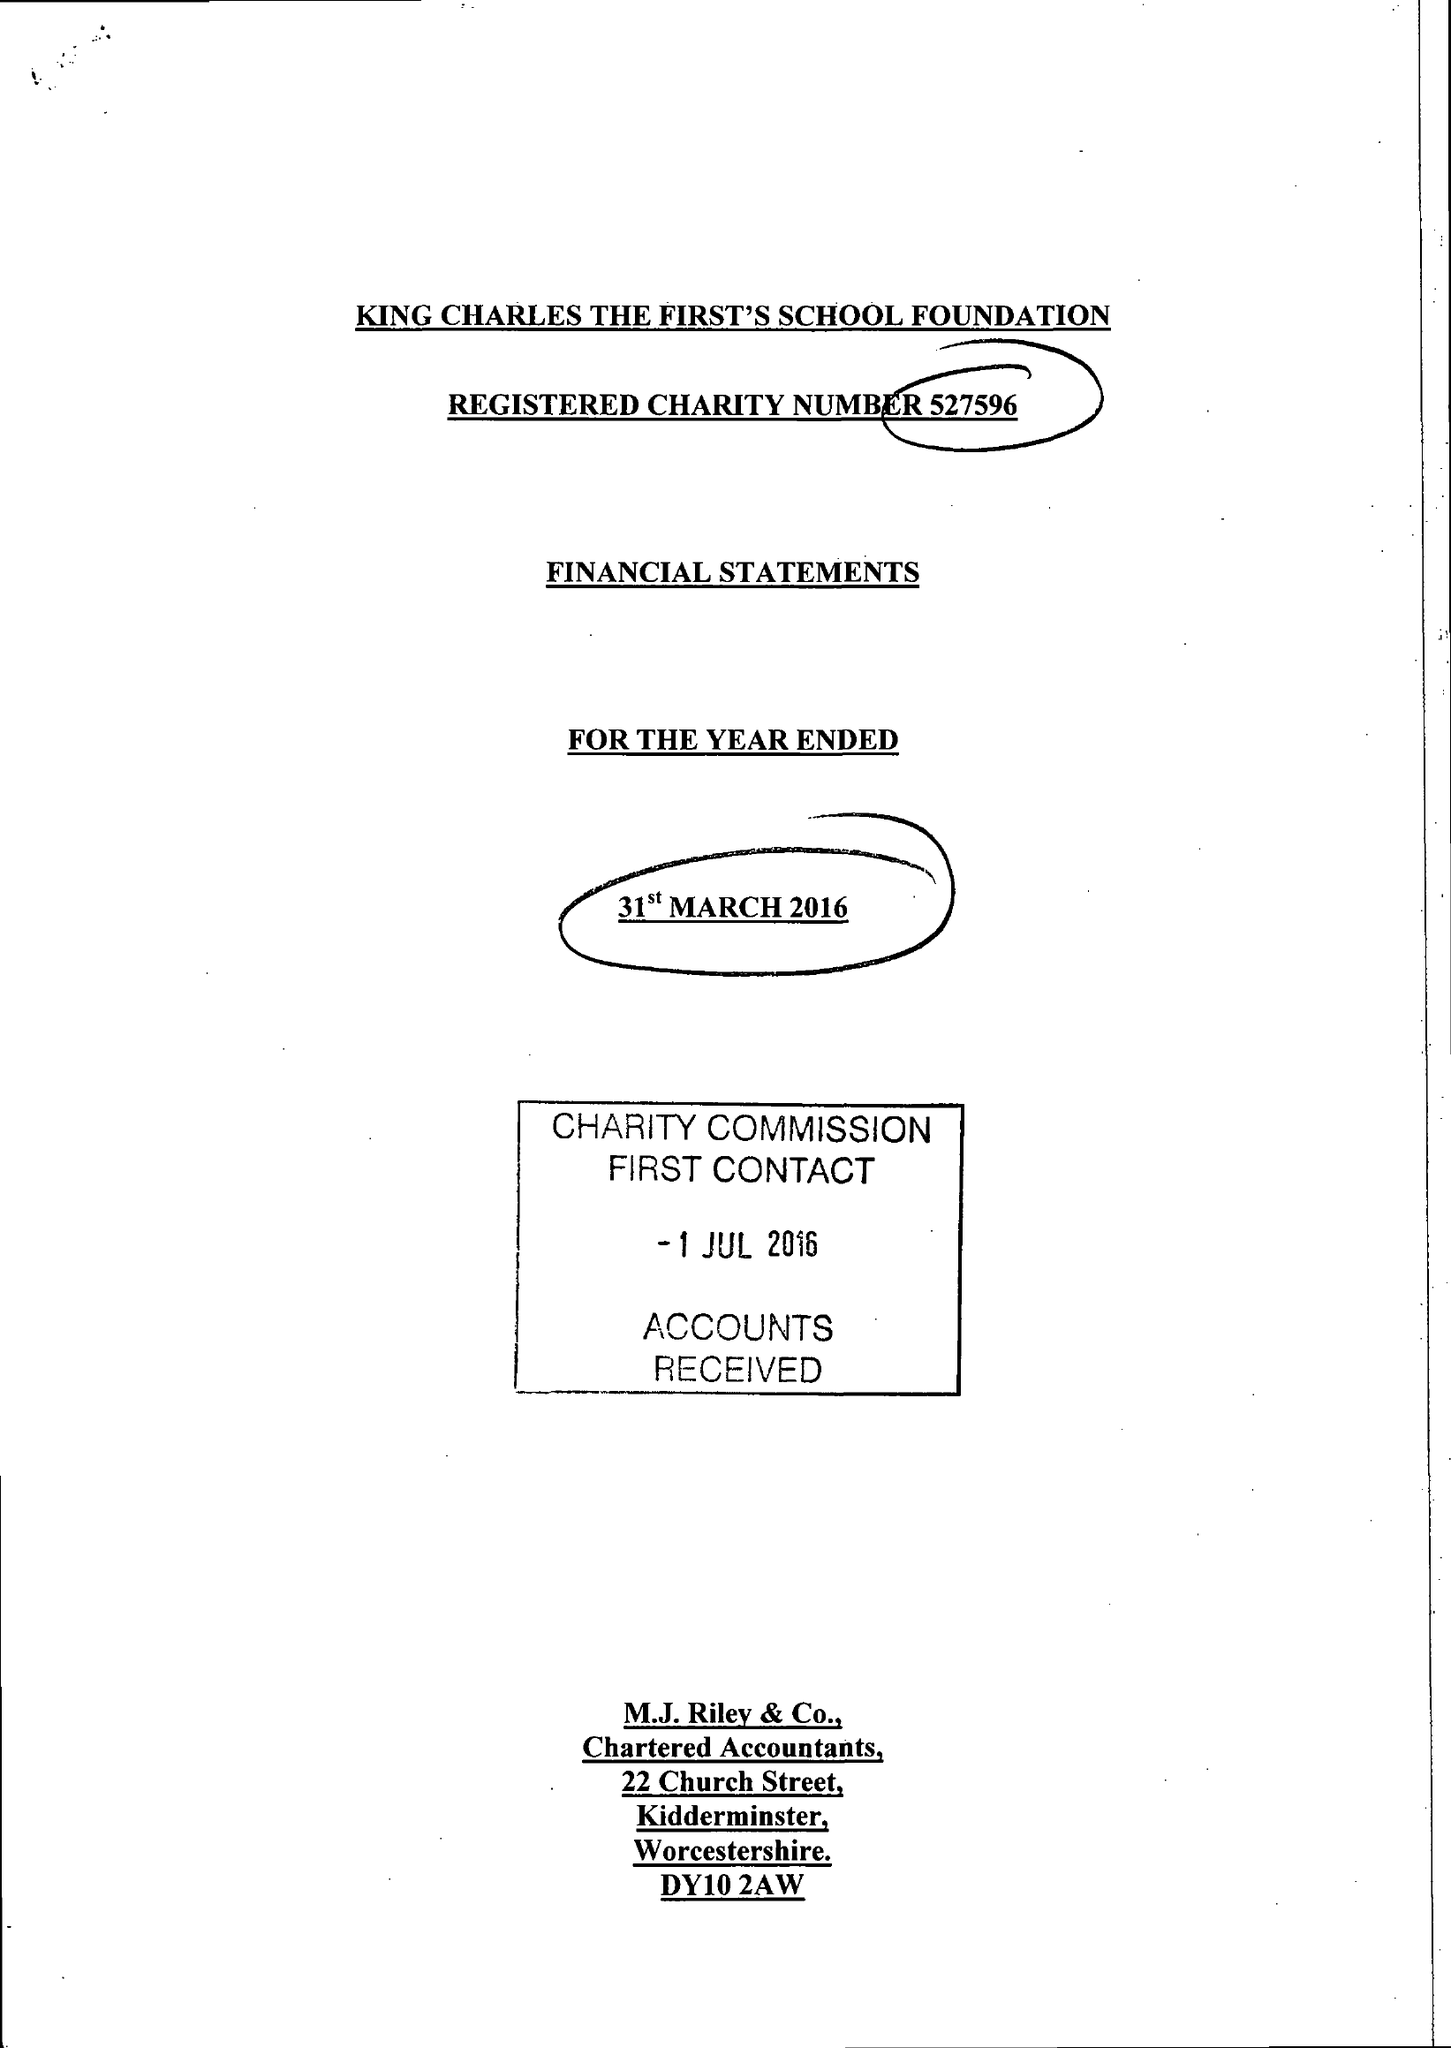What is the value for the spending_annually_in_british_pounds?
Answer the question using a single word or phrase. 63860.00 